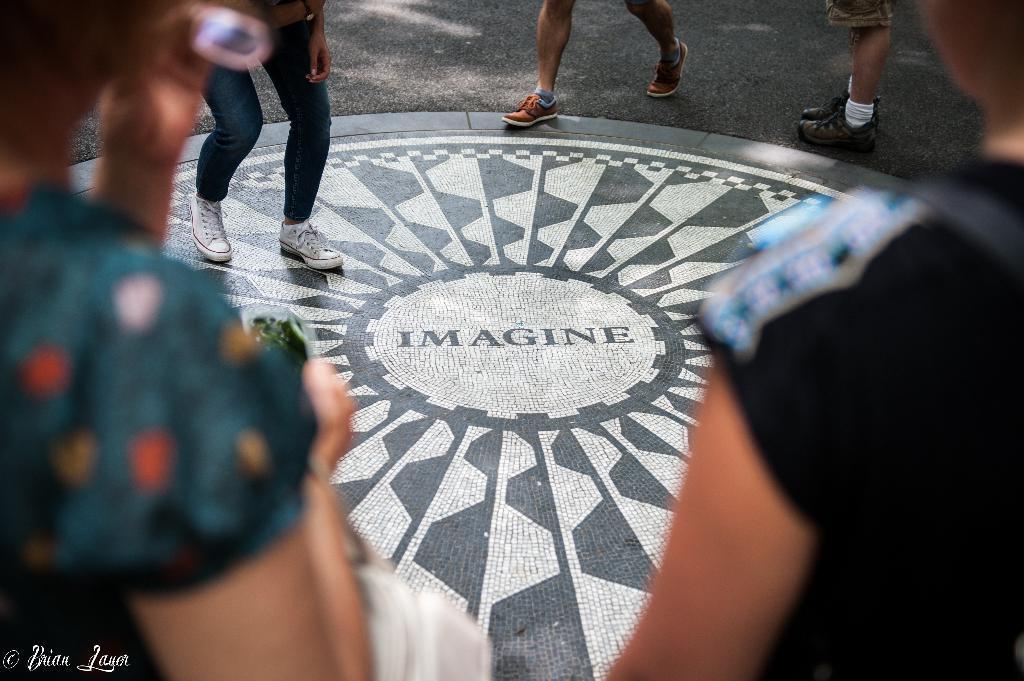Please provide a concise description of this image. In this image we can see persons standing on the road. 